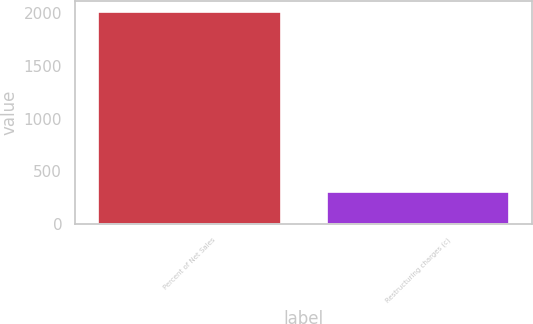Convert chart. <chart><loc_0><loc_0><loc_500><loc_500><bar_chart><fcel>Percent of Net Sales<fcel>Restructuring charges (c)<nl><fcel>2015<fcel>305.7<nl></chart> 